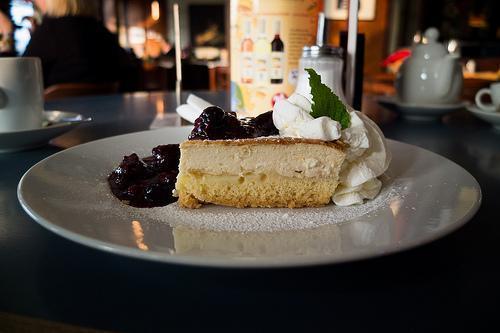How many teapots are there?
Give a very brief answer. 1. 